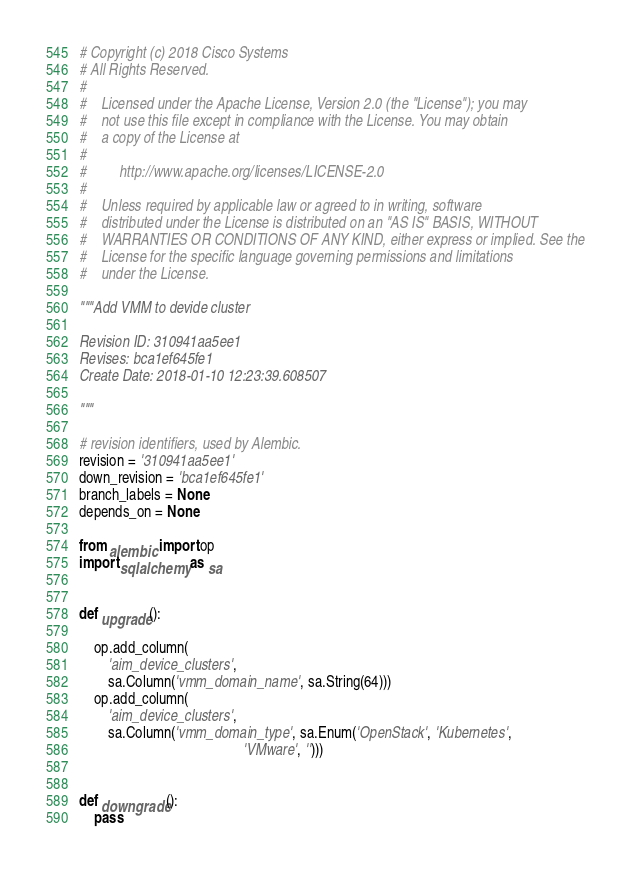<code> <loc_0><loc_0><loc_500><loc_500><_Python_># Copyright (c) 2018 Cisco Systems
# All Rights Reserved.
#
#    Licensed under the Apache License, Version 2.0 (the "License"); you may
#    not use this file except in compliance with the License. You may obtain
#    a copy of the License at
#
#         http://www.apache.org/licenses/LICENSE-2.0
#
#    Unless required by applicable law or agreed to in writing, software
#    distributed under the License is distributed on an "AS IS" BASIS, WITHOUT
#    WARRANTIES OR CONDITIONS OF ANY KIND, either express or implied. See the
#    License for the specific language governing permissions and limitations
#    under the License.

"""Add VMM to devide cluster

Revision ID: 310941aa5ee1
Revises: bca1ef645fe1
Create Date: 2018-01-10 12:23:39.608507

"""

# revision identifiers, used by Alembic.
revision = '310941aa5ee1'
down_revision = 'bca1ef645fe1'
branch_labels = None
depends_on = None

from alembic import op
import sqlalchemy as sa


def upgrade():

    op.add_column(
        'aim_device_clusters',
        sa.Column('vmm_domain_name', sa.String(64)))
    op.add_column(
        'aim_device_clusters',
        sa.Column('vmm_domain_type', sa.Enum('OpenStack', 'Kubernetes',
                                             'VMware', '')))


def downgrade():
    pass
</code> 